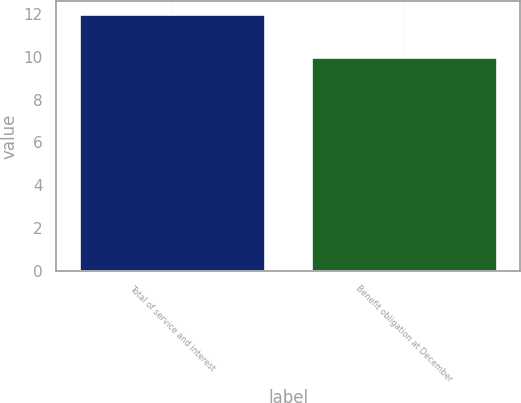Convert chart. <chart><loc_0><loc_0><loc_500><loc_500><bar_chart><fcel>Total of service and interest<fcel>Benefit obligation at December<nl><fcel>12<fcel>10<nl></chart> 